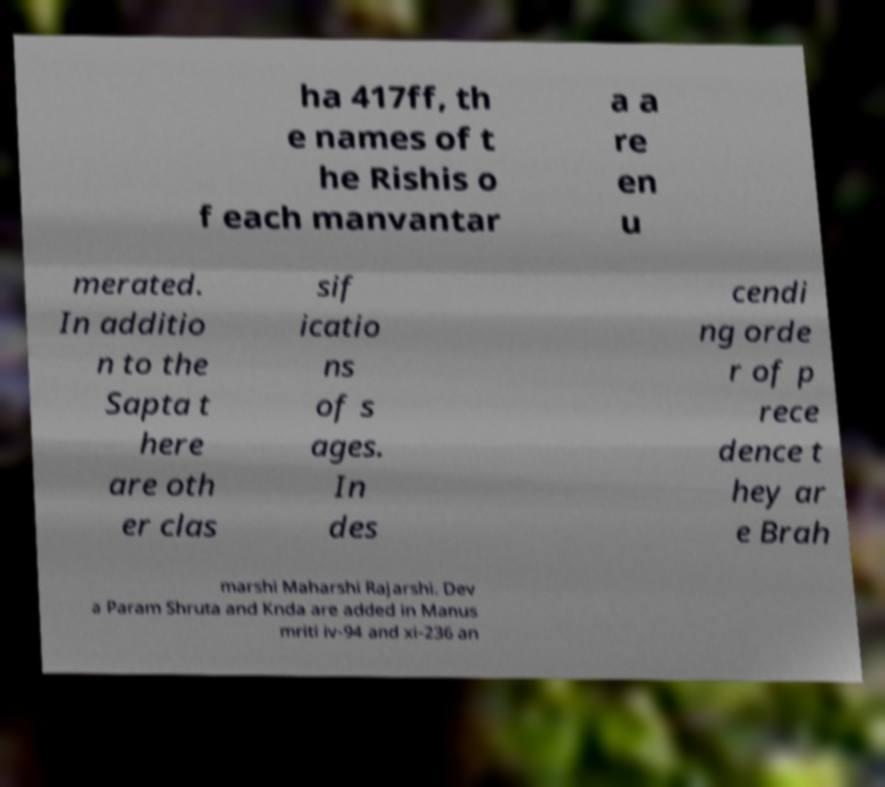Can you accurately transcribe the text from the provided image for me? ha 417ff, th e names of t he Rishis o f each manvantar a a re en u merated. In additio n to the Sapta t here are oth er clas sif icatio ns of s ages. In des cendi ng orde r of p rece dence t hey ar e Brah marshi Maharshi Rajarshi. Dev a Param Shruta and Knda are added in Manus mriti iv-94 and xi-236 an 